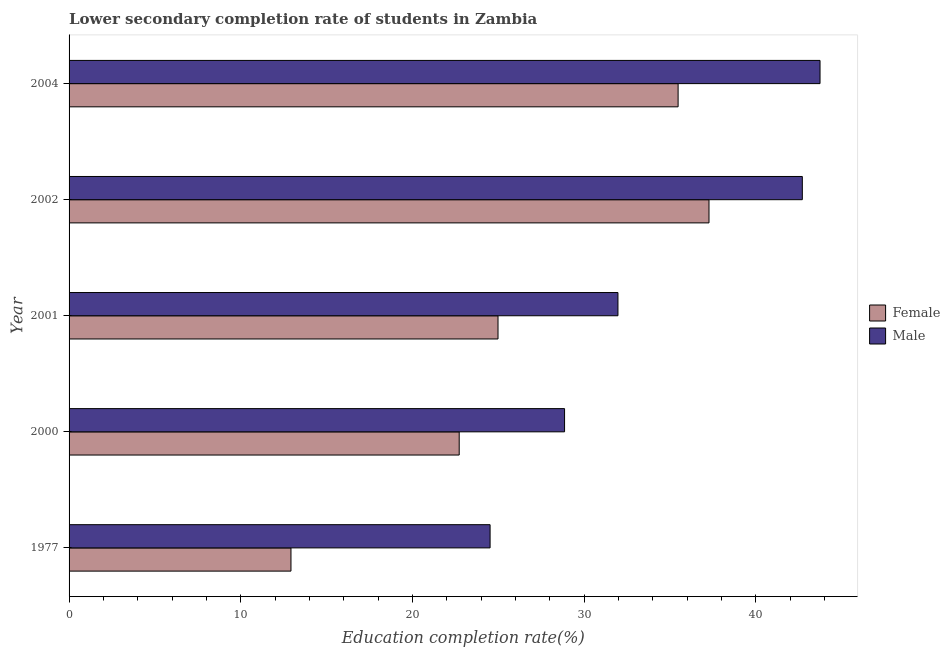How many different coloured bars are there?
Offer a very short reply. 2. How many groups of bars are there?
Give a very brief answer. 5. Are the number of bars per tick equal to the number of legend labels?
Your answer should be very brief. Yes. How many bars are there on the 2nd tick from the bottom?
Make the answer very short. 2. What is the label of the 1st group of bars from the top?
Offer a terse response. 2004. What is the education completion rate of male students in 2000?
Offer a very short reply. 28.85. Across all years, what is the maximum education completion rate of female students?
Keep it short and to the point. 37.27. Across all years, what is the minimum education completion rate of male students?
Offer a terse response. 24.52. What is the total education completion rate of male students in the graph?
Your answer should be compact. 171.76. What is the difference between the education completion rate of male students in 2000 and that in 2002?
Offer a very short reply. -13.85. What is the difference between the education completion rate of male students in 2002 and the education completion rate of female students in 1977?
Your answer should be very brief. 29.78. What is the average education completion rate of male students per year?
Your response must be concise. 34.35. In the year 2004, what is the difference between the education completion rate of female students and education completion rate of male students?
Your response must be concise. -8.27. What is the ratio of the education completion rate of female students in 1977 to that in 2002?
Provide a short and direct response. 0.35. What is the difference between the highest and the second highest education completion rate of female students?
Provide a short and direct response. 1.8. What is the difference between the highest and the lowest education completion rate of male students?
Your answer should be compact. 19.21. Is the sum of the education completion rate of female students in 2000 and 2002 greater than the maximum education completion rate of male students across all years?
Give a very brief answer. Yes. How many bars are there?
Your answer should be compact. 10. Are all the bars in the graph horizontal?
Offer a very short reply. Yes. How many years are there in the graph?
Your answer should be very brief. 5. Are the values on the major ticks of X-axis written in scientific E-notation?
Keep it short and to the point. No. Does the graph contain grids?
Make the answer very short. No. Where does the legend appear in the graph?
Offer a terse response. Center right. How are the legend labels stacked?
Keep it short and to the point. Vertical. What is the title of the graph?
Your answer should be compact. Lower secondary completion rate of students in Zambia. Does "Arms exports" appear as one of the legend labels in the graph?
Ensure brevity in your answer.  No. What is the label or title of the X-axis?
Make the answer very short. Education completion rate(%). What is the Education completion rate(%) in Female in 1977?
Keep it short and to the point. 12.92. What is the Education completion rate(%) in Male in 1977?
Your answer should be compact. 24.52. What is the Education completion rate(%) of Female in 2000?
Your answer should be very brief. 22.72. What is the Education completion rate(%) in Male in 2000?
Your response must be concise. 28.85. What is the Education completion rate(%) in Female in 2001?
Offer a very short reply. 24.98. What is the Education completion rate(%) of Male in 2001?
Make the answer very short. 31.96. What is the Education completion rate(%) in Female in 2002?
Keep it short and to the point. 37.27. What is the Education completion rate(%) in Male in 2002?
Your response must be concise. 42.7. What is the Education completion rate(%) in Female in 2004?
Provide a succinct answer. 35.47. What is the Education completion rate(%) of Male in 2004?
Keep it short and to the point. 43.73. Across all years, what is the maximum Education completion rate(%) in Female?
Make the answer very short. 37.27. Across all years, what is the maximum Education completion rate(%) of Male?
Provide a succinct answer. 43.73. Across all years, what is the minimum Education completion rate(%) of Female?
Your response must be concise. 12.92. Across all years, what is the minimum Education completion rate(%) of Male?
Provide a short and direct response. 24.52. What is the total Education completion rate(%) in Female in the graph?
Provide a succinct answer. 133.35. What is the total Education completion rate(%) of Male in the graph?
Your response must be concise. 171.76. What is the difference between the Education completion rate(%) of Female in 1977 and that in 2000?
Offer a terse response. -9.8. What is the difference between the Education completion rate(%) in Male in 1977 and that in 2000?
Your answer should be compact. -4.34. What is the difference between the Education completion rate(%) of Female in 1977 and that in 2001?
Offer a very short reply. -12.06. What is the difference between the Education completion rate(%) in Male in 1977 and that in 2001?
Offer a very short reply. -7.45. What is the difference between the Education completion rate(%) of Female in 1977 and that in 2002?
Your answer should be compact. -24.34. What is the difference between the Education completion rate(%) of Male in 1977 and that in 2002?
Your answer should be very brief. -18.18. What is the difference between the Education completion rate(%) of Female in 1977 and that in 2004?
Provide a succinct answer. -22.54. What is the difference between the Education completion rate(%) of Male in 1977 and that in 2004?
Keep it short and to the point. -19.21. What is the difference between the Education completion rate(%) in Female in 2000 and that in 2001?
Keep it short and to the point. -2.26. What is the difference between the Education completion rate(%) in Male in 2000 and that in 2001?
Provide a short and direct response. -3.11. What is the difference between the Education completion rate(%) of Female in 2000 and that in 2002?
Make the answer very short. -14.55. What is the difference between the Education completion rate(%) of Male in 2000 and that in 2002?
Provide a succinct answer. -13.85. What is the difference between the Education completion rate(%) of Female in 2000 and that in 2004?
Give a very brief answer. -12.75. What is the difference between the Education completion rate(%) of Male in 2000 and that in 2004?
Offer a very short reply. -14.88. What is the difference between the Education completion rate(%) in Female in 2001 and that in 2002?
Give a very brief answer. -12.29. What is the difference between the Education completion rate(%) in Male in 2001 and that in 2002?
Provide a short and direct response. -10.74. What is the difference between the Education completion rate(%) in Female in 2001 and that in 2004?
Your answer should be compact. -10.49. What is the difference between the Education completion rate(%) in Male in 2001 and that in 2004?
Keep it short and to the point. -11.77. What is the difference between the Education completion rate(%) of Female in 2002 and that in 2004?
Your answer should be very brief. 1.8. What is the difference between the Education completion rate(%) of Male in 2002 and that in 2004?
Offer a very short reply. -1.03. What is the difference between the Education completion rate(%) in Female in 1977 and the Education completion rate(%) in Male in 2000?
Give a very brief answer. -15.93. What is the difference between the Education completion rate(%) in Female in 1977 and the Education completion rate(%) in Male in 2001?
Your answer should be compact. -19.04. What is the difference between the Education completion rate(%) of Female in 1977 and the Education completion rate(%) of Male in 2002?
Offer a terse response. -29.78. What is the difference between the Education completion rate(%) in Female in 1977 and the Education completion rate(%) in Male in 2004?
Provide a short and direct response. -30.81. What is the difference between the Education completion rate(%) in Female in 2000 and the Education completion rate(%) in Male in 2001?
Offer a very short reply. -9.24. What is the difference between the Education completion rate(%) in Female in 2000 and the Education completion rate(%) in Male in 2002?
Your response must be concise. -19.98. What is the difference between the Education completion rate(%) of Female in 2000 and the Education completion rate(%) of Male in 2004?
Give a very brief answer. -21.01. What is the difference between the Education completion rate(%) in Female in 2001 and the Education completion rate(%) in Male in 2002?
Your answer should be very brief. -17.72. What is the difference between the Education completion rate(%) of Female in 2001 and the Education completion rate(%) of Male in 2004?
Offer a very short reply. -18.75. What is the difference between the Education completion rate(%) in Female in 2002 and the Education completion rate(%) in Male in 2004?
Keep it short and to the point. -6.47. What is the average Education completion rate(%) in Female per year?
Give a very brief answer. 26.67. What is the average Education completion rate(%) in Male per year?
Give a very brief answer. 34.35. In the year 1977, what is the difference between the Education completion rate(%) of Female and Education completion rate(%) of Male?
Make the answer very short. -11.6. In the year 2000, what is the difference between the Education completion rate(%) in Female and Education completion rate(%) in Male?
Provide a succinct answer. -6.14. In the year 2001, what is the difference between the Education completion rate(%) of Female and Education completion rate(%) of Male?
Your answer should be compact. -6.98. In the year 2002, what is the difference between the Education completion rate(%) in Female and Education completion rate(%) in Male?
Keep it short and to the point. -5.43. In the year 2004, what is the difference between the Education completion rate(%) in Female and Education completion rate(%) in Male?
Your answer should be compact. -8.26. What is the ratio of the Education completion rate(%) of Female in 1977 to that in 2000?
Offer a very short reply. 0.57. What is the ratio of the Education completion rate(%) of Male in 1977 to that in 2000?
Make the answer very short. 0.85. What is the ratio of the Education completion rate(%) in Female in 1977 to that in 2001?
Offer a terse response. 0.52. What is the ratio of the Education completion rate(%) of Male in 1977 to that in 2001?
Your response must be concise. 0.77. What is the ratio of the Education completion rate(%) of Female in 1977 to that in 2002?
Ensure brevity in your answer.  0.35. What is the ratio of the Education completion rate(%) in Male in 1977 to that in 2002?
Give a very brief answer. 0.57. What is the ratio of the Education completion rate(%) in Female in 1977 to that in 2004?
Offer a terse response. 0.36. What is the ratio of the Education completion rate(%) in Male in 1977 to that in 2004?
Provide a short and direct response. 0.56. What is the ratio of the Education completion rate(%) in Female in 2000 to that in 2001?
Provide a short and direct response. 0.91. What is the ratio of the Education completion rate(%) in Male in 2000 to that in 2001?
Provide a succinct answer. 0.9. What is the ratio of the Education completion rate(%) in Female in 2000 to that in 2002?
Your answer should be very brief. 0.61. What is the ratio of the Education completion rate(%) of Male in 2000 to that in 2002?
Ensure brevity in your answer.  0.68. What is the ratio of the Education completion rate(%) in Female in 2000 to that in 2004?
Ensure brevity in your answer.  0.64. What is the ratio of the Education completion rate(%) in Male in 2000 to that in 2004?
Keep it short and to the point. 0.66. What is the ratio of the Education completion rate(%) in Female in 2001 to that in 2002?
Offer a terse response. 0.67. What is the ratio of the Education completion rate(%) of Male in 2001 to that in 2002?
Offer a very short reply. 0.75. What is the ratio of the Education completion rate(%) in Female in 2001 to that in 2004?
Provide a succinct answer. 0.7. What is the ratio of the Education completion rate(%) of Male in 2001 to that in 2004?
Provide a succinct answer. 0.73. What is the ratio of the Education completion rate(%) of Female in 2002 to that in 2004?
Provide a short and direct response. 1.05. What is the ratio of the Education completion rate(%) of Male in 2002 to that in 2004?
Keep it short and to the point. 0.98. What is the difference between the highest and the second highest Education completion rate(%) in Female?
Keep it short and to the point. 1.8. What is the difference between the highest and the second highest Education completion rate(%) in Male?
Offer a terse response. 1.03. What is the difference between the highest and the lowest Education completion rate(%) in Female?
Your answer should be compact. 24.34. What is the difference between the highest and the lowest Education completion rate(%) of Male?
Offer a very short reply. 19.21. 